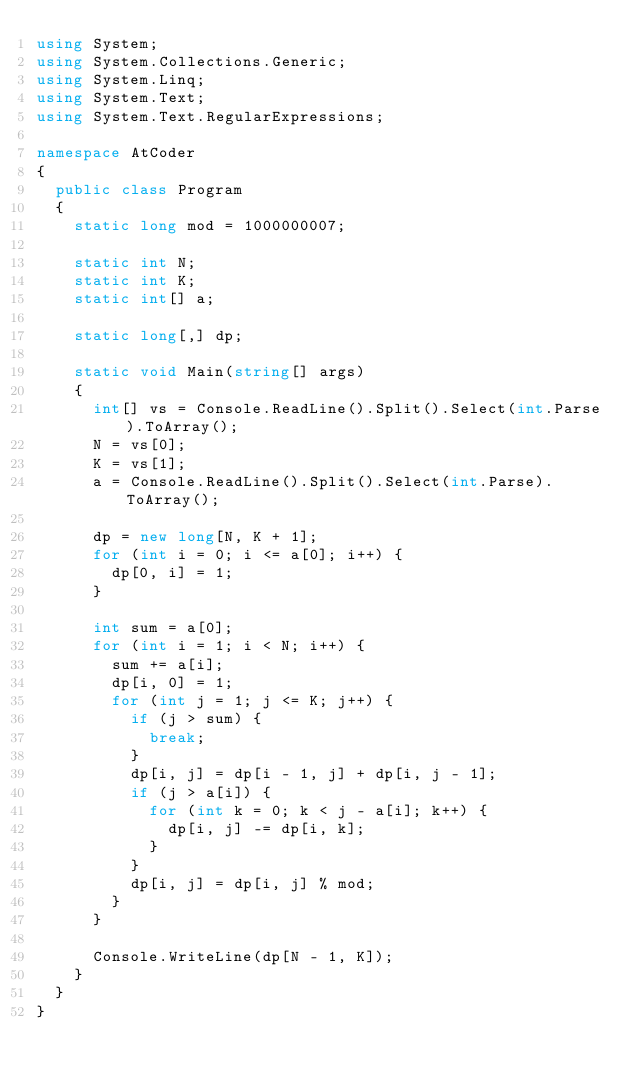Convert code to text. <code><loc_0><loc_0><loc_500><loc_500><_C#_>using System;
using System.Collections.Generic;
using System.Linq;
using System.Text;
using System.Text.RegularExpressions;

namespace AtCoder
{
	public class Program
	{
		static long mod = 1000000007;

		static int N;
		static int K;
		static int[] a;

		static long[,] dp;

		static void Main(string[] args)
		{
			int[] vs = Console.ReadLine().Split().Select(int.Parse).ToArray();
			N = vs[0];
			K = vs[1];
			a = Console.ReadLine().Split().Select(int.Parse).ToArray();

			dp = new long[N, K + 1];
			for (int i = 0; i <= a[0]; i++) {
				dp[0, i] = 1;
			}

			int sum = a[0];
			for (int i = 1; i < N; i++) {
				sum += a[i];
				dp[i, 0] = 1;
				for (int j = 1; j <= K; j++) {
					if (j > sum) {
						break;
					}
					dp[i, j] = dp[i - 1, j] + dp[i, j - 1];
					if (j > a[i]) {
						for (int k = 0; k < j - a[i]; k++) {
							dp[i, j] -= dp[i, k];
						}
					}
					dp[i, j] = dp[i, j] % mod;
				}
			}

			Console.WriteLine(dp[N - 1, K]);
		}
	}
}
</code> 